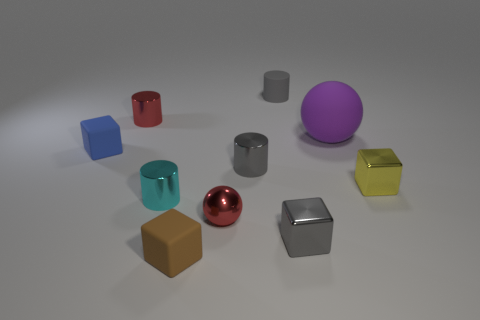Subtract all brown matte cubes. How many cubes are left? 3 Subtract all brown spheres. How many gray cylinders are left? 2 Subtract 1 blocks. How many blocks are left? 3 Subtract all gray blocks. How many blocks are left? 3 Subtract all blocks. How many objects are left? 6 Subtract all purple cylinders. Subtract all green cubes. How many cylinders are left? 4 Add 6 small gray cylinders. How many small gray cylinders are left? 8 Add 2 balls. How many balls exist? 4 Subtract 1 yellow blocks. How many objects are left? 9 Subtract all small brown shiny cubes. Subtract all big rubber spheres. How many objects are left? 9 